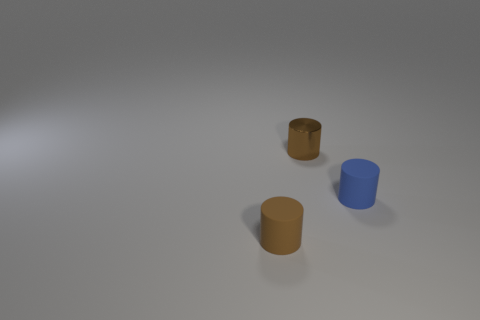Subtract all tiny brown cylinders. How many cylinders are left? 1 Add 1 small red cylinders. How many objects exist? 4 Subtract 1 cylinders. How many cylinders are left? 2 Add 3 large cyan rubber blocks. How many large cyan rubber blocks exist? 3 Subtract all brown cylinders. How many cylinders are left? 1 Subtract 0 red blocks. How many objects are left? 3 Subtract all cyan cylinders. Subtract all brown blocks. How many cylinders are left? 3 Subtract all red blocks. How many brown cylinders are left? 2 Subtract all purple objects. Subtract all small brown things. How many objects are left? 1 Add 2 small brown objects. How many small brown objects are left? 4 